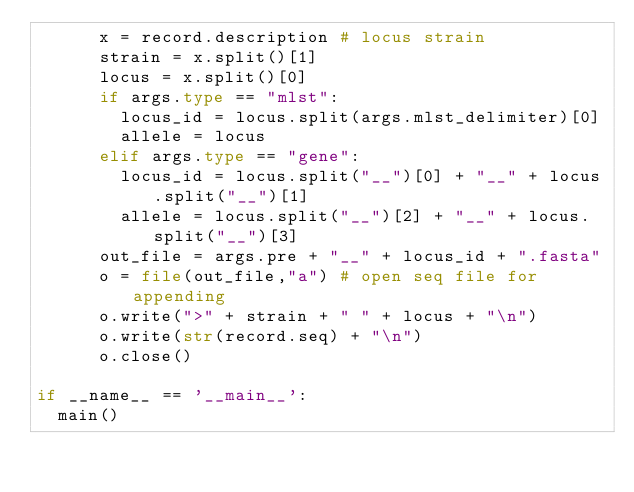<code> <loc_0><loc_0><loc_500><loc_500><_Python_>			x = record.description # locus strain
			strain = x.split()[1]
			locus = x.split()[0]
			if args.type == "mlst":
				locus_id = locus.split(args.mlst_delimiter)[0]
				allele = locus
			elif args.type == "gene":
				locus_id = locus.split("__")[0] + "__" + locus.split("__")[1]
				allele = locus.split("__")[2] + "__" + locus.split("__")[3]
			out_file = args.pre + "__" + locus_id + ".fasta"
			o = file(out_file,"a") # open seq file for appending
			o.write(">" + strain + " " + locus + "\n")
			o.write(str(record.seq) + "\n")
			o.close()

if __name__ == '__main__':
	main()
</code> 